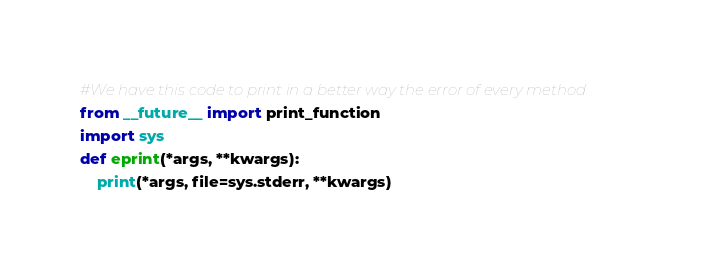<code> <loc_0><loc_0><loc_500><loc_500><_Python_>#We have this code to print in a better way the error of every method
from __future__ import print_function
import sys
def eprint(*args, **kwargs):
    print(*args, file=sys.stderr, **kwargs)
</code> 